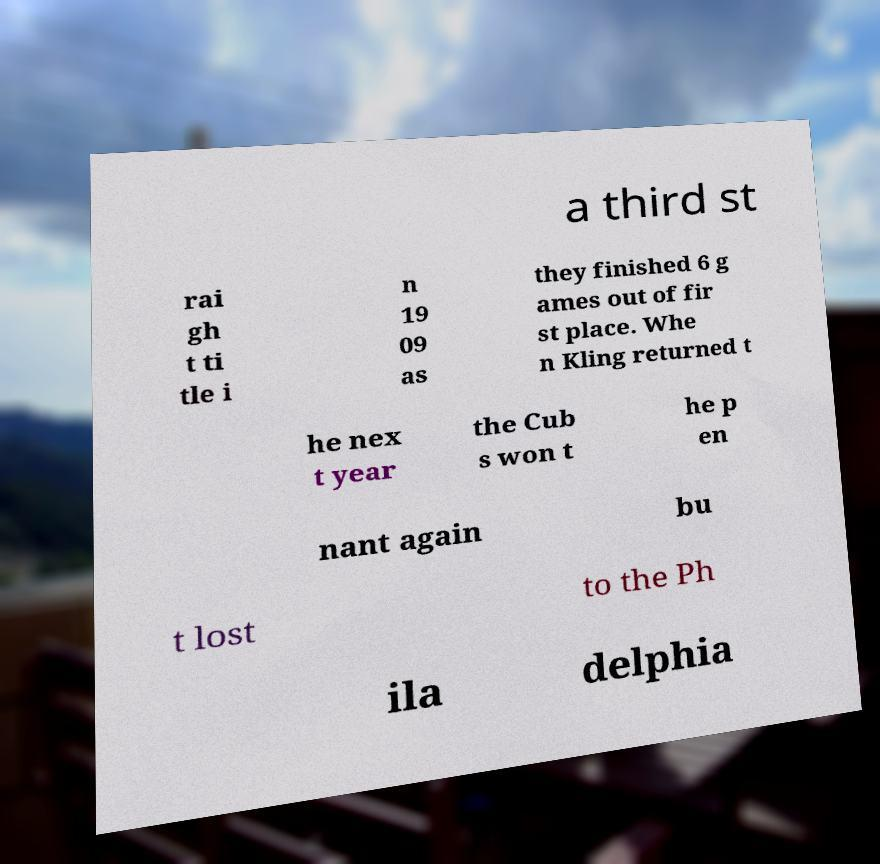Can you read and provide the text displayed in the image?This photo seems to have some interesting text. Can you extract and type it out for me? a third st rai gh t ti tle i n 19 09 as they finished 6 g ames out of fir st place. Whe n Kling returned t he nex t year the Cub s won t he p en nant again bu t lost to the Ph ila delphia 